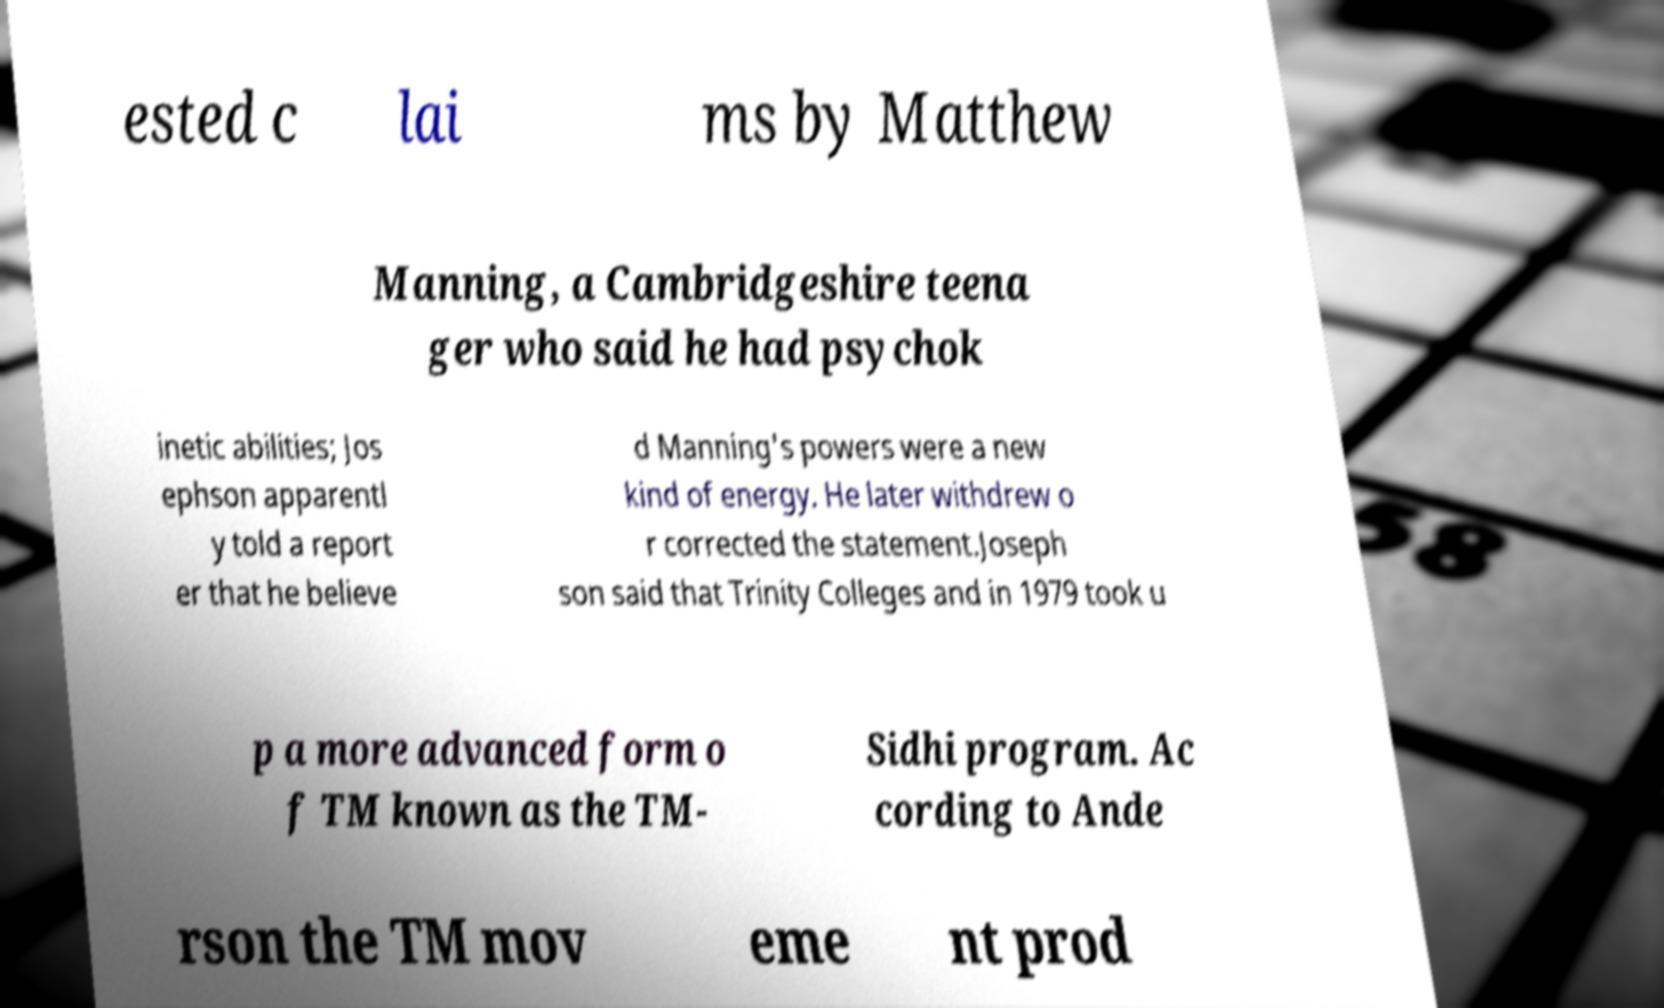Can you accurately transcribe the text from the provided image for me? ested c lai ms by Matthew Manning, a Cambridgeshire teena ger who said he had psychok inetic abilities; Jos ephson apparentl y told a report er that he believe d Manning's powers were a new kind of energy. He later withdrew o r corrected the statement.Joseph son said that Trinity Colleges and in 1979 took u p a more advanced form o f TM known as the TM- Sidhi program. Ac cording to Ande rson the TM mov eme nt prod 